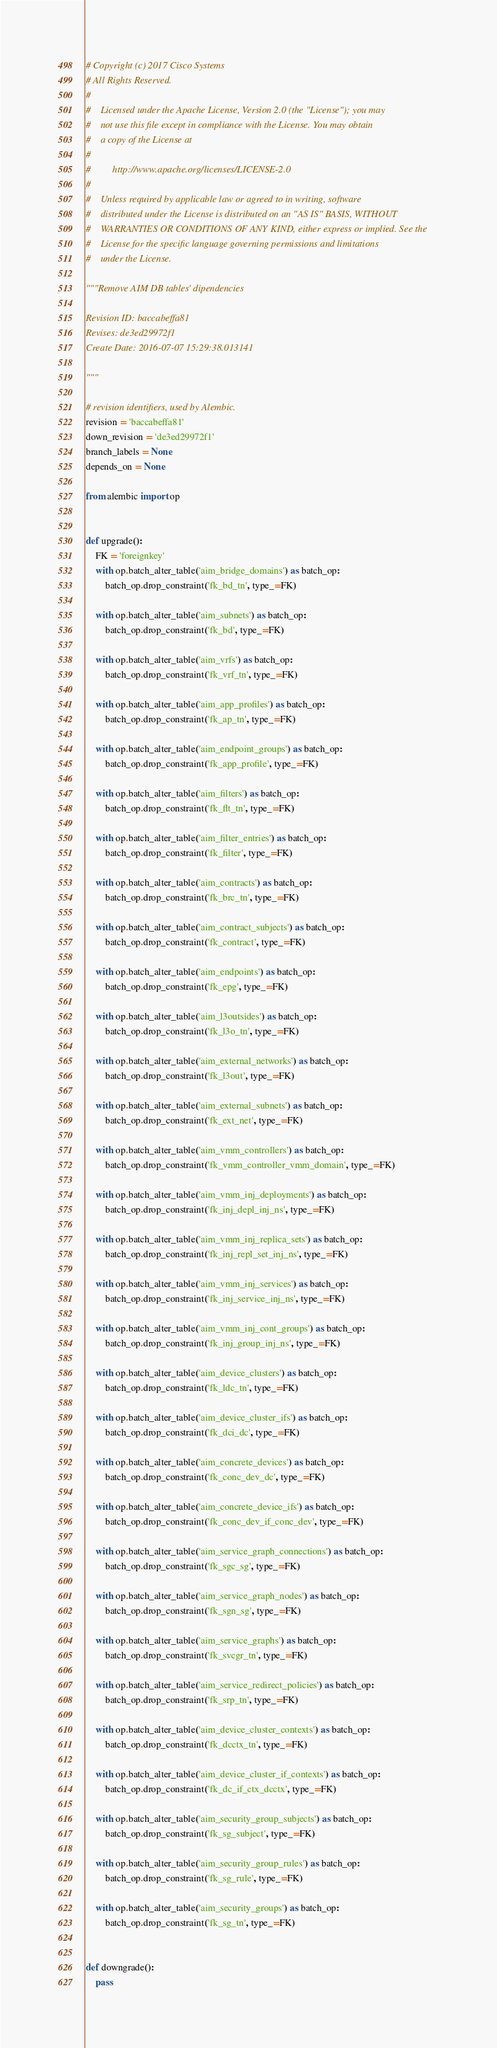Convert code to text. <code><loc_0><loc_0><loc_500><loc_500><_Python_># Copyright (c) 2017 Cisco Systems
# All Rights Reserved.
#
#    Licensed under the Apache License, Version 2.0 (the "License"); you may
#    not use this file except in compliance with the License. You may obtain
#    a copy of the License at
#
#         http://www.apache.org/licenses/LICENSE-2.0
#
#    Unless required by applicable law or agreed to in writing, software
#    distributed under the License is distributed on an "AS IS" BASIS, WITHOUT
#    WARRANTIES OR CONDITIONS OF ANY KIND, either express or implied. See the
#    License for the specific language governing permissions and limitations
#    under the License.

"""Remove AIM DB tables' dipendencies

Revision ID: baccabeffa81
Revises: de3ed29972f1
Create Date: 2016-07-07 15:29:38.013141

"""

# revision identifiers, used by Alembic.
revision = 'baccabeffa81'
down_revision = 'de3ed29972f1'
branch_labels = None
depends_on = None

from alembic import op


def upgrade():
    FK = 'foreignkey'
    with op.batch_alter_table('aim_bridge_domains') as batch_op:
        batch_op.drop_constraint('fk_bd_tn', type_=FK)

    with op.batch_alter_table('aim_subnets') as batch_op:
        batch_op.drop_constraint('fk_bd', type_=FK)

    with op.batch_alter_table('aim_vrfs') as batch_op:
        batch_op.drop_constraint('fk_vrf_tn', type_=FK)

    with op.batch_alter_table('aim_app_profiles') as batch_op:
        batch_op.drop_constraint('fk_ap_tn', type_=FK)

    with op.batch_alter_table('aim_endpoint_groups') as batch_op:
        batch_op.drop_constraint('fk_app_profile', type_=FK)

    with op.batch_alter_table('aim_filters') as batch_op:
        batch_op.drop_constraint('fk_flt_tn', type_=FK)

    with op.batch_alter_table('aim_filter_entries') as batch_op:
        batch_op.drop_constraint('fk_filter', type_=FK)

    with op.batch_alter_table('aim_contracts') as batch_op:
        batch_op.drop_constraint('fk_brc_tn', type_=FK)

    with op.batch_alter_table('aim_contract_subjects') as batch_op:
        batch_op.drop_constraint('fk_contract', type_=FK)

    with op.batch_alter_table('aim_endpoints') as batch_op:
        batch_op.drop_constraint('fk_epg', type_=FK)

    with op.batch_alter_table('aim_l3outsides') as batch_op:
        batch_op.drop_constraint('fk_l3o_tn', type_=FK)

    with op.batch_alter_table('aim_external_networks') as batch_op:
        batch_op.drop_constraint('fk_l3out', type_=FK)

    with op.batch_alter_table('aim_external_subnets') as batch_op:
        batch_op.drop_constraint('fk_ext_net', type_=FK)

    with op.batch_alter_table('aim_vmm_controllers') as batch_op:
        batch_op.drop_constraint('fk_vmm_controller_vmm_domain', type_=FK)

    with op.batch_alter_table('aim_vmm_inj_deployments') as batch_op:
        batch_op.drop_constraint('fk_inj_depl_inj_ns', type_=FK)

    with op.batch_alter_table('aim_vmm_inj_replica_sets') as batch_op:
        batch_op.drop_constraint('fk_inj_repl_set_inj_ns', type_=FK)

    with op.batch_alter_table('aim_vmm_inj_services') as batch_op:
        batch_op.drop_constraint('fk_inj_service_inj_ns', type_=FK)

    with op.batch_alter_table('aim_vmm_inj_cont_groups') as batch_op:
        batch_op.drop_constraint('fk_inj_group_inj_ns', type_=FK)

    with op.batch_alter_table('aim_device_clusters') as batch_op:
        batch_op.drop_constraint('fk_ldc_tn', type_=FK)

    with op.batch_alter_table('aim_device_cluster_ifs') as batch_op:
        batch_op.drop_constraint('fk_dci_dc', type_=FK)

    with op.batch_alter_table('aim_concrete_devices') as batch_op:
        batch_op.drop_constraint('fk_conc_dev_dc', type_=FK)

    with op.batch_alter_table('aim_concrete_device_ifs') as batch_op:
        batch_op.drop_constraint('fk_conc_dev_if_conc_dev', type_=FK)

    with op.batch_alter_table('aim_service_graph_connections') as batch_op:
        batch_op.drop_constraint('fk_sgc_sg', type_=FK)

    with op.batch_alter_table('aim_service_graph_nodes') as batch_op:
        batch_op.drop_constraint('fk_sgn_sg', type_=FK)

    with op.batch_alter_table('aim_service_graphs') as batch_op:
        batch_op.drop_constraint('fk_svcgr_tn', type_=FK)

    with op.batch_alter_table('aim_service_redirect_policies') as batch_op:
        batch_op.drop_constraint('fk_srp_tn', type_=FK)

    with op.batch_alter_table('aim_device_cluster_contexts') as batch_op:
        batch_op.drop_constraint('fk_dcctx_tn', type_=FK)

    with op.batch_alter_table('aim_device_cluster_if_contexts') as batch_op:
        batch_op.drop_constraint('fk_dc_if_ctx_dcctx', type_=FK)

    with op.batch_alter_table('aim_security_group_subjects') as batch_op:
        batch_op.drop_constraint('fk_sg_subject', type_=FK)

    with op.batch_alter_table('aim_security_group_rules') as batch_op:
        batch_op.drop_constraint('fk_sg_rule', type_=FK)

    with op.batch_alter_table('aim_security_groups') as batch_op:
        batch_op.drop_constraint('fk_sg_tn', type_=FK)


def downgrade():
    pass
</code> 